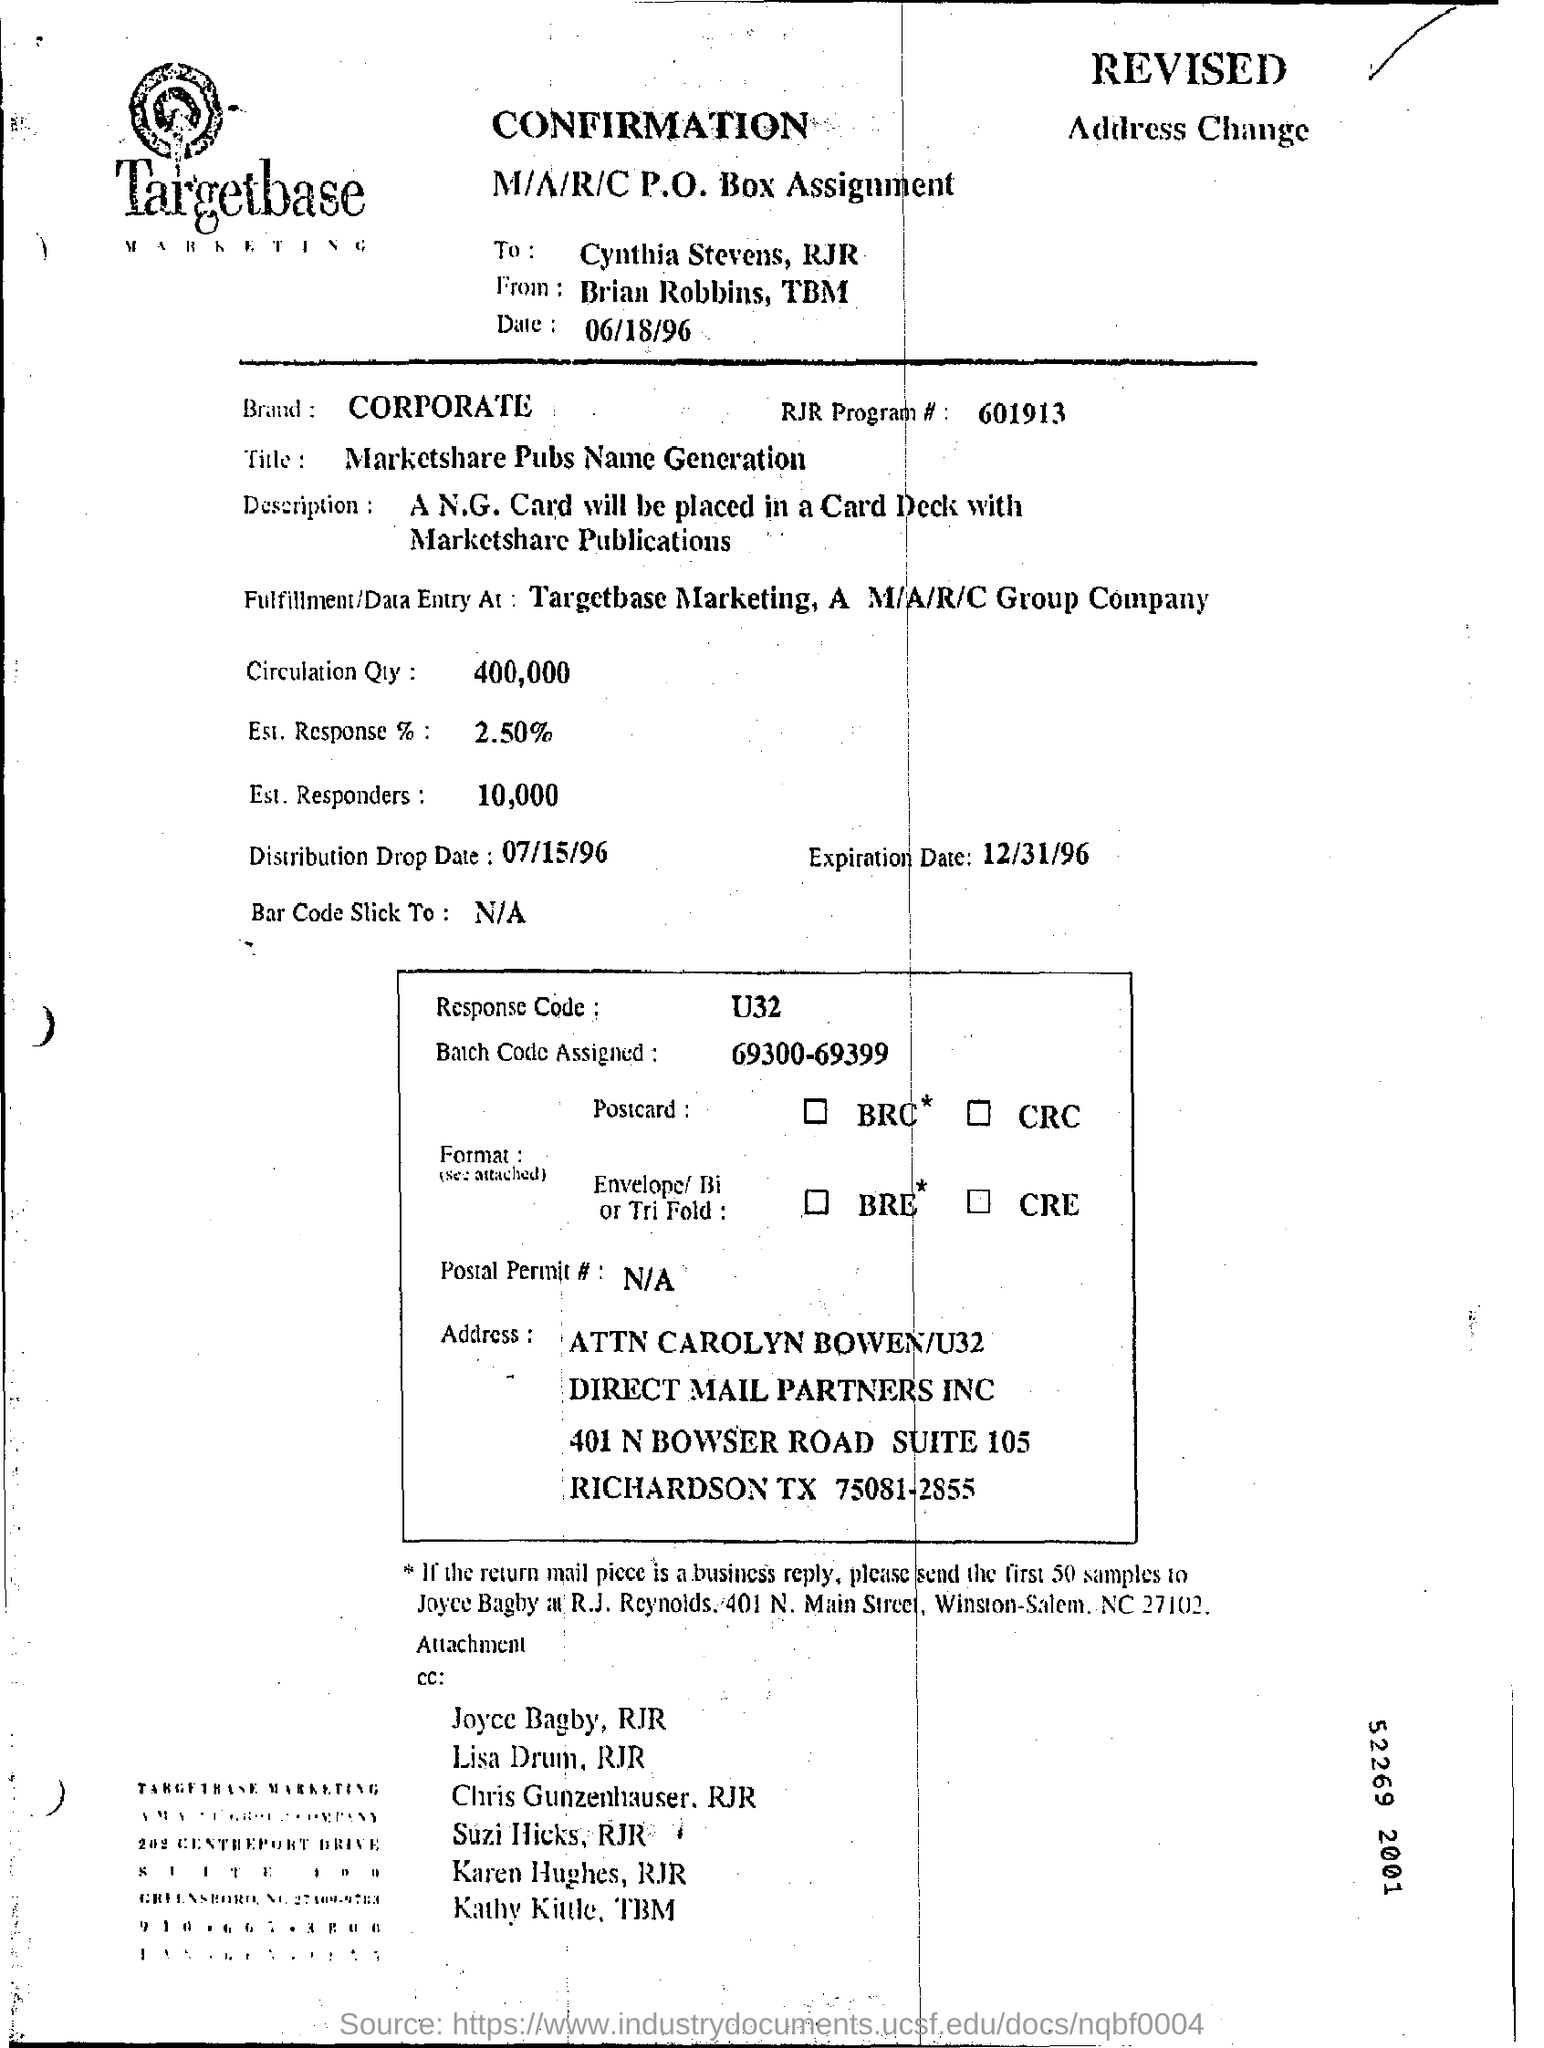Which company is mentioned in the letter head?
Your answer should be compact. Targetbase Marketing. To whom the document is addressed to?
Offer a terse response. Cynthia stevens , rjr. What is the Circulation Qty as per the document?
Offer a terse response. 400,000. What is the Expiration date mentioned in the document?
Your answer should be compact. 12/31/96. What is the Est. Response %  as per the document?
Your answer should be very brief. 2.50%. How many Est. Responders are there as per the document?
Give a very brief answer. 10,000. What is the Distribution Drop Date mentioned in the document?
Give a very brief answer. 07/15/96. 